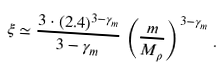<formula> <loc_0><loc_0><loc_500><loc_500>\xi \simeq \frac { 3 \cdot ( 2 . 4 ) ^ { 3 - \gamma _ { m } } } { 3 - \gamma _ { m } } \, \left ( \frac { m } { M _ { \rho } } \right ) ^ { 3 - \gamma _ { m } } \, .</formula> 